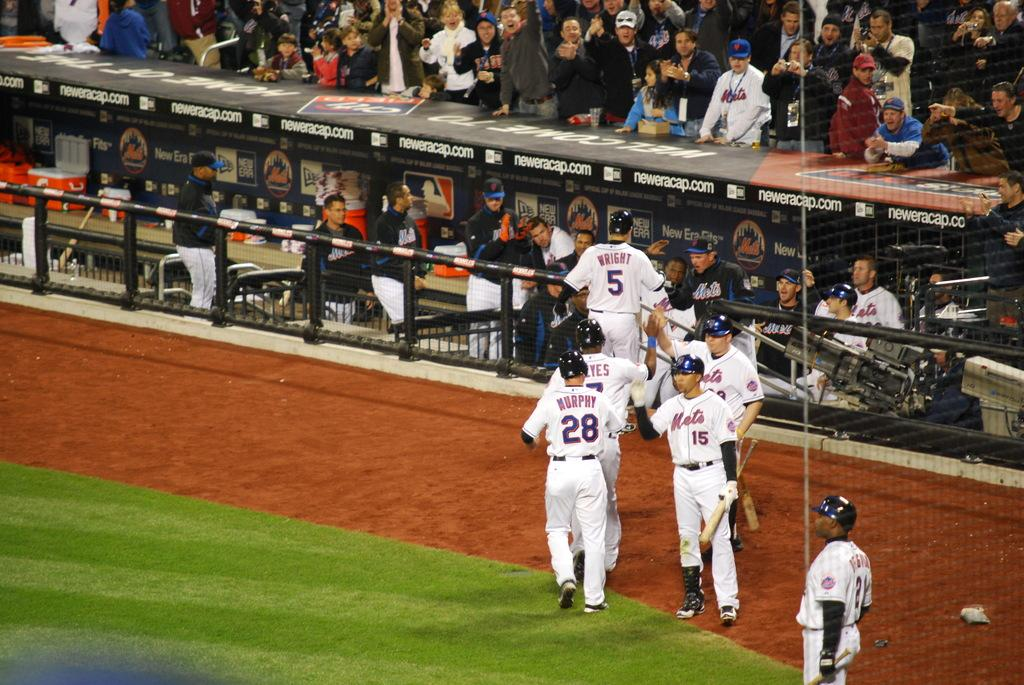<image>
Share a concise interpretation of the image provided. Players from the Mets baseball time lined up in opposite directions giving each other high fives as they walk to the dugout. 